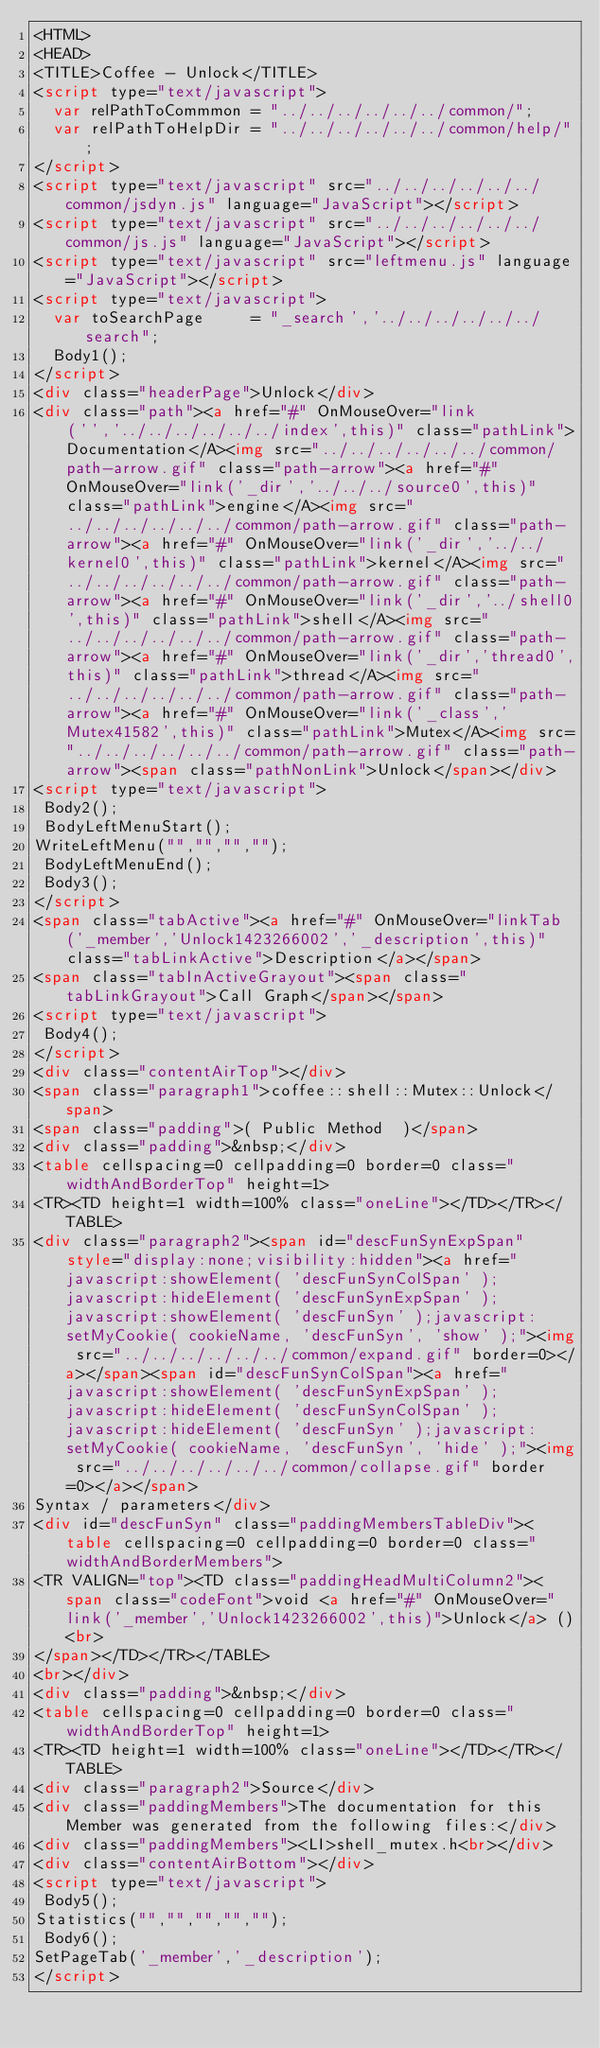<code> <loc_0><loc_0><loc_500><loc_500><_HTML_><HTML>
<HEAD>
<TITLE>Coffee - Unlock</TITLE>
<script type="text/javascript">
  var relPathToCommmon = "../../../../../../common/";
  var relPathToHelpDir = "../../../../../../common/help/";
</script>
<script type="text/javascript" src="../../../../../../common/jsdyn.js" language="JavaScript"></script>
<script type="text/javascript" src="../../../../../../common/js.js" language="JavaScript"></script>
<script type="text/javascript" src="leftmenu.js" language="JavaScript"></script>
<script type="text/javascript">
  var toSearchPage     = "_search','../../../../../../search";
  Body1();
</script>
<div class="headerPage">Unlock</div>
<div class="path"><a href="#" OnMouseOver="link('','../../../../../../index',this)" class="pathLink">Documentation</A><img src="../../../../../../common/path-arrow.gif" class="path-arrow"><a href="#" OnMouseOver="link('_dir','../../../source0',this)" class="pathLink">engine</A><img src="../../../../../../common/path-arrow.gif" class="path-arrow"><a href="#" OnMouseOver="link('_dir','../../kernel0',this)" class="pathLink">kernel</A><img src="../../../../../../common/path-arrow.gif" class="path-arrow"><a href="#" OnMouseOver="link('_dir','../shell0',this)" class="pathLink">shell</A><img src="../../../../../../common/path-arrow.gif" class="path-arrow"><a href="#" OnMouseOver="link('_dir','thread0',this)" class="pathLink">thread</A><img src="../../../../../../common/path-arrow.gif" class="path-arrow"><a href="#" OnMouseOver="link('_class','Mutex41582',this)" class="pathLink">Mutex</A><img src="../../../../../../common/path-arrow.gif" class="path-arrow"><span class="pathNonLink">Unlock</span></div>
<script type="text/javascript">
 Body2();
 BodyLeftMenuStart();
WriteLeftMenu("","","","");
 BodyLeftMenuEnd();
 Body3();
</script>
<span class="tabActive"><a href="#" OnMouseOver="linkTab('_member','Unlock1423266002','_description',this)" class="tabLinkActive">Description</a></span>
<span class="tabInActiveGrayout"><span class="tabLinkGrayout">Call Graph</span></span>
<script type="text/javascript">
 Body4();
</script>
<div class="contentAirTop"></div>
<span class="paragraph1">coffee::shell::Mutex::Unlock</span>
<span class="padding">( Public Method  )</span>
<div class="padding">&nbsp;</div>
<table cellspacing=0 cellpadding=0 border=0 class="widthAndBorderTop" height=1>
<TR><TD height=1 width=100% class="oneLine"></TD></TR></TABLE>
<div class="paragraph2"><span id="descFunSynExpSpan" style="display:none;visibility:hidden"><a href="javascript:showElement( 'descFunSynColSpan' );javascript:hideElement( 'descFunSynExpSpan' );javascript:showElement( 'descFunSyn' );javascript:setMyCookie( cookieName, 'descFunSyn', 'show' );"><img src="../../../../../../common/expand.gif" border=0></a></span><span id="descFunSynColSpan"><a href="javascript:showElement( 'descFunSynExpSpan' );javascript:hideElement( 'descFunSynColSpan' );javascript:hideElement( 'descFunSyn' );javascript:setMyCookie( cookieName, 'descFunSyn', 'hide' );"><img src="../../../../../../common/collapse.gif" border=0></a></span>
Syntax / parameters</div>
<div id="descFunSyn" class="paddingMembersTableDiv"><table cellspacing=0 cellpadding=0 border=0 class="widthAndBorderMembers">
<TR VALIGN="top"><TD class="paddingHeadMultiColumn2"><span class="codeFont">void <a href="#" OnMouseOver="link('_member','Unlock1423266002',this)">Unlock</a> ()<br>
</span></TD></TR></TABLE>
<br></div>
<div class="padding">&nbsp;</div>
<table cellspacing=0 cellpadding=0 border=0 class="widthAndBorderTop" height=1>
<TR><TD height=1 width=100% class="oneLine"></TD></TR></TABLE>
<div class="paragraph2">Source</div>
<div class="paddingMembers">The documentation for this Member was generated from the following files:</div>
<div class="paddingMembers"><LI>shell_mutex.h<br></div>
<div class="contentAirBottom"></div>
<script type="text/javascript">
 Body5();
Statistics("","","","","");
 Body6();
SetPageTab('_member','_description');
</script>
</code> 